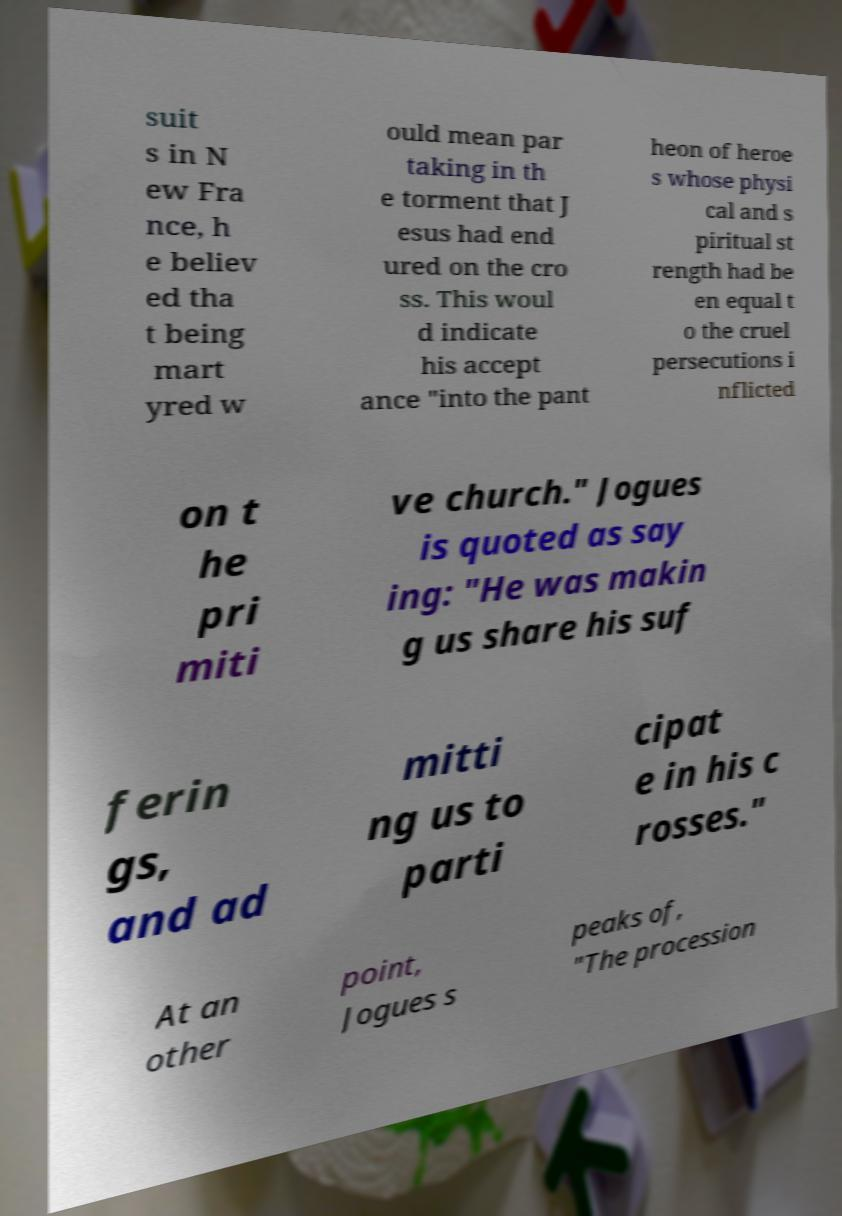For documentation purposes, I need the text within this image transcribed. Could you provide that? suit s in N ew Fra nce, h e believ ed tha t being mart yred w ould mean par taking in th e torment that J esus had end ured on the cro ss. This woul d indicate his accept ance "into the pant heon of heroe s whose physi cal and s piritual st rength had be en equal t o the cruel persecutions i nflicted on t he pri miti ve church." Jogues is quoted as say ing: "He was makin g us share his suf ferin gs, and ad mitti ng us to parti cipat e in his c rosses." At an other point, Jogues s peaks of, "The procession 